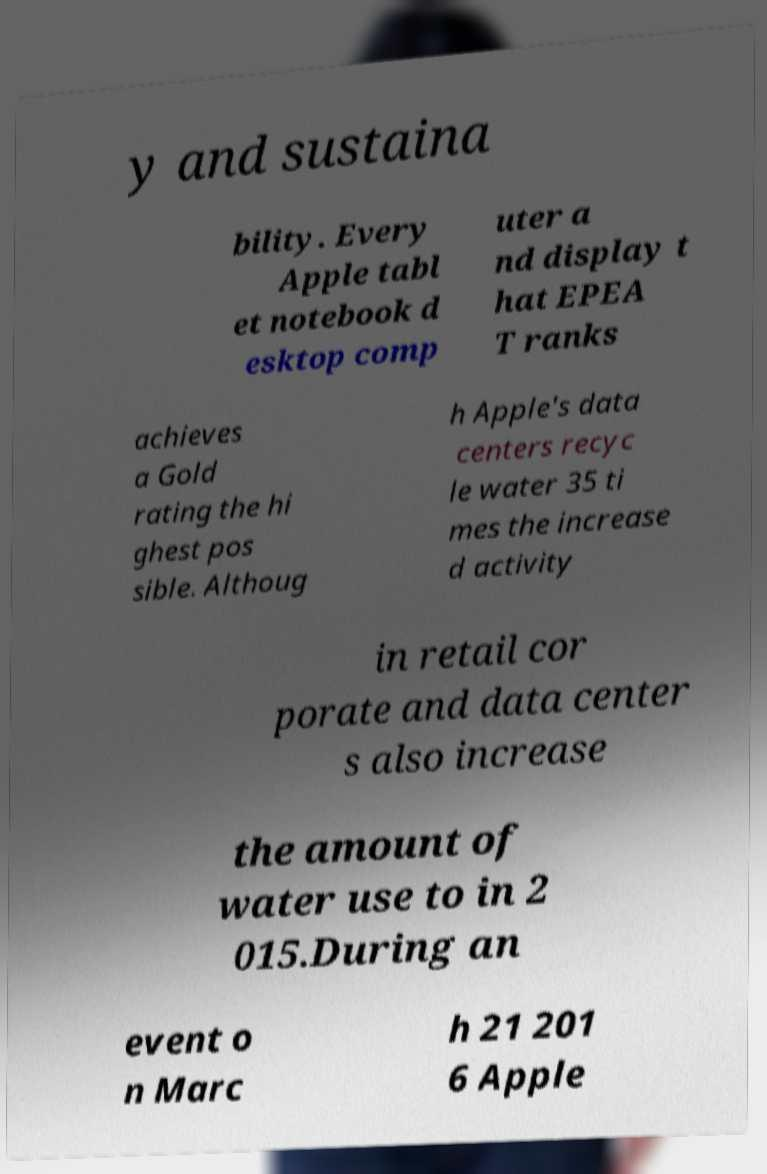Please identify and transcribe the text found in this image. y and sustaina bility. Every Apple tabl et notebook d esktop comp uter a nd display t hat EPEA T ranks achieves a Gold rating the hi ghest pos sible. Althoug h Apple's data centers recyc le water 35 ti mes the increase d activity in retail cor porate and data center s also increase the amount of water use to in 2 015.During an event o n Marc h 21 201 6 Apple 